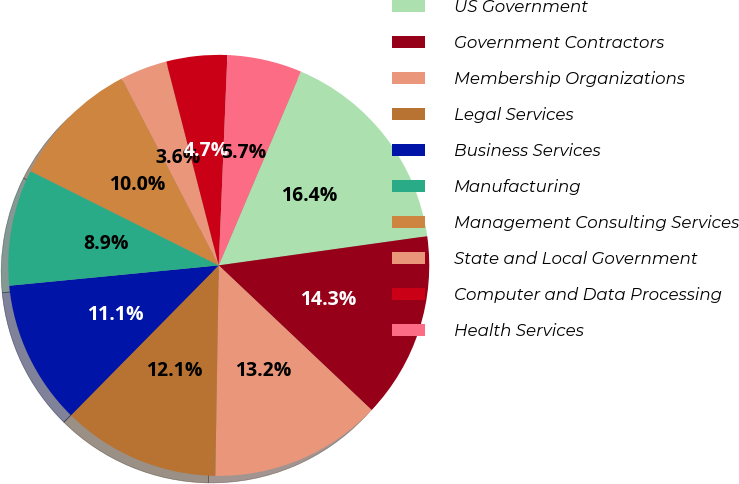Convert chart to OTSL. <chart><loc_0><loc_0><loc_500><loc_500><pie_chart><fcel>US Government<fcel>Government Contractors<fcel>Membership Organizations<fcel>Legal Services<fcel>Business Services<fcel>Manufacturing<fcel>Management Consulting Services<fcel>State and Local Government<fcel>Computer and Data Processing<fcel>Health Services<nl><fcel>16.4%<fcel>14.27%<fcel>13.2%<fcel>12.13%<fcel>11.07%<fcel>8.93%<fcel>10.0%<fcel>3.6%<fcel>4.66%<fcel>5.73%<nl></chart> 